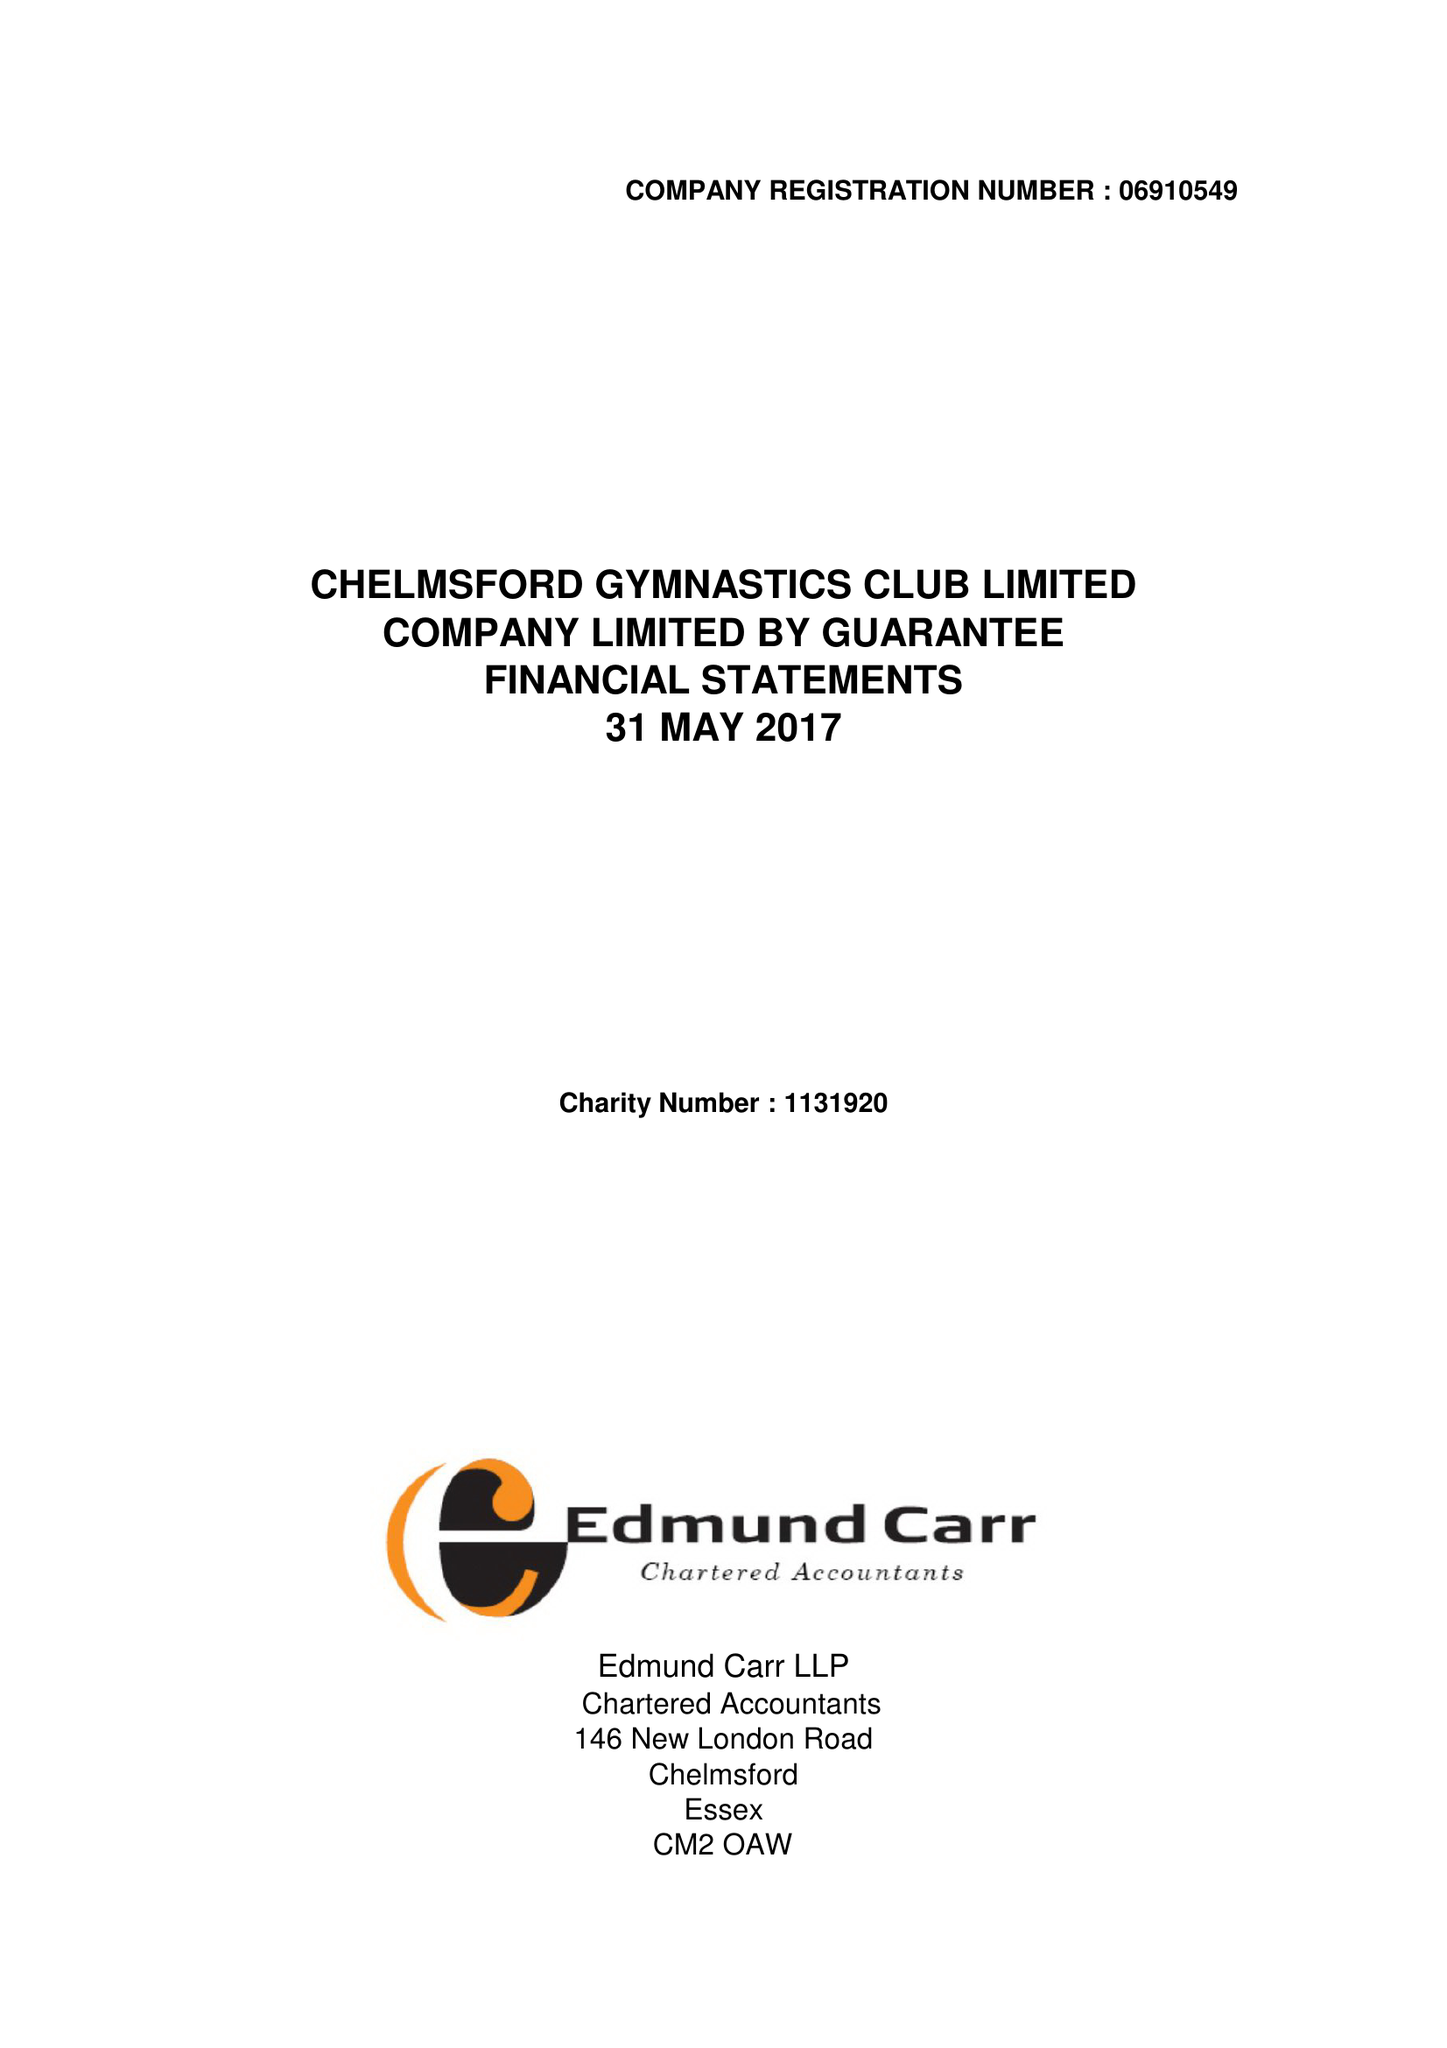What is the value for the spending_annually_in_british_pounds?
Answer the question using a single word or phrase. 439362.00 